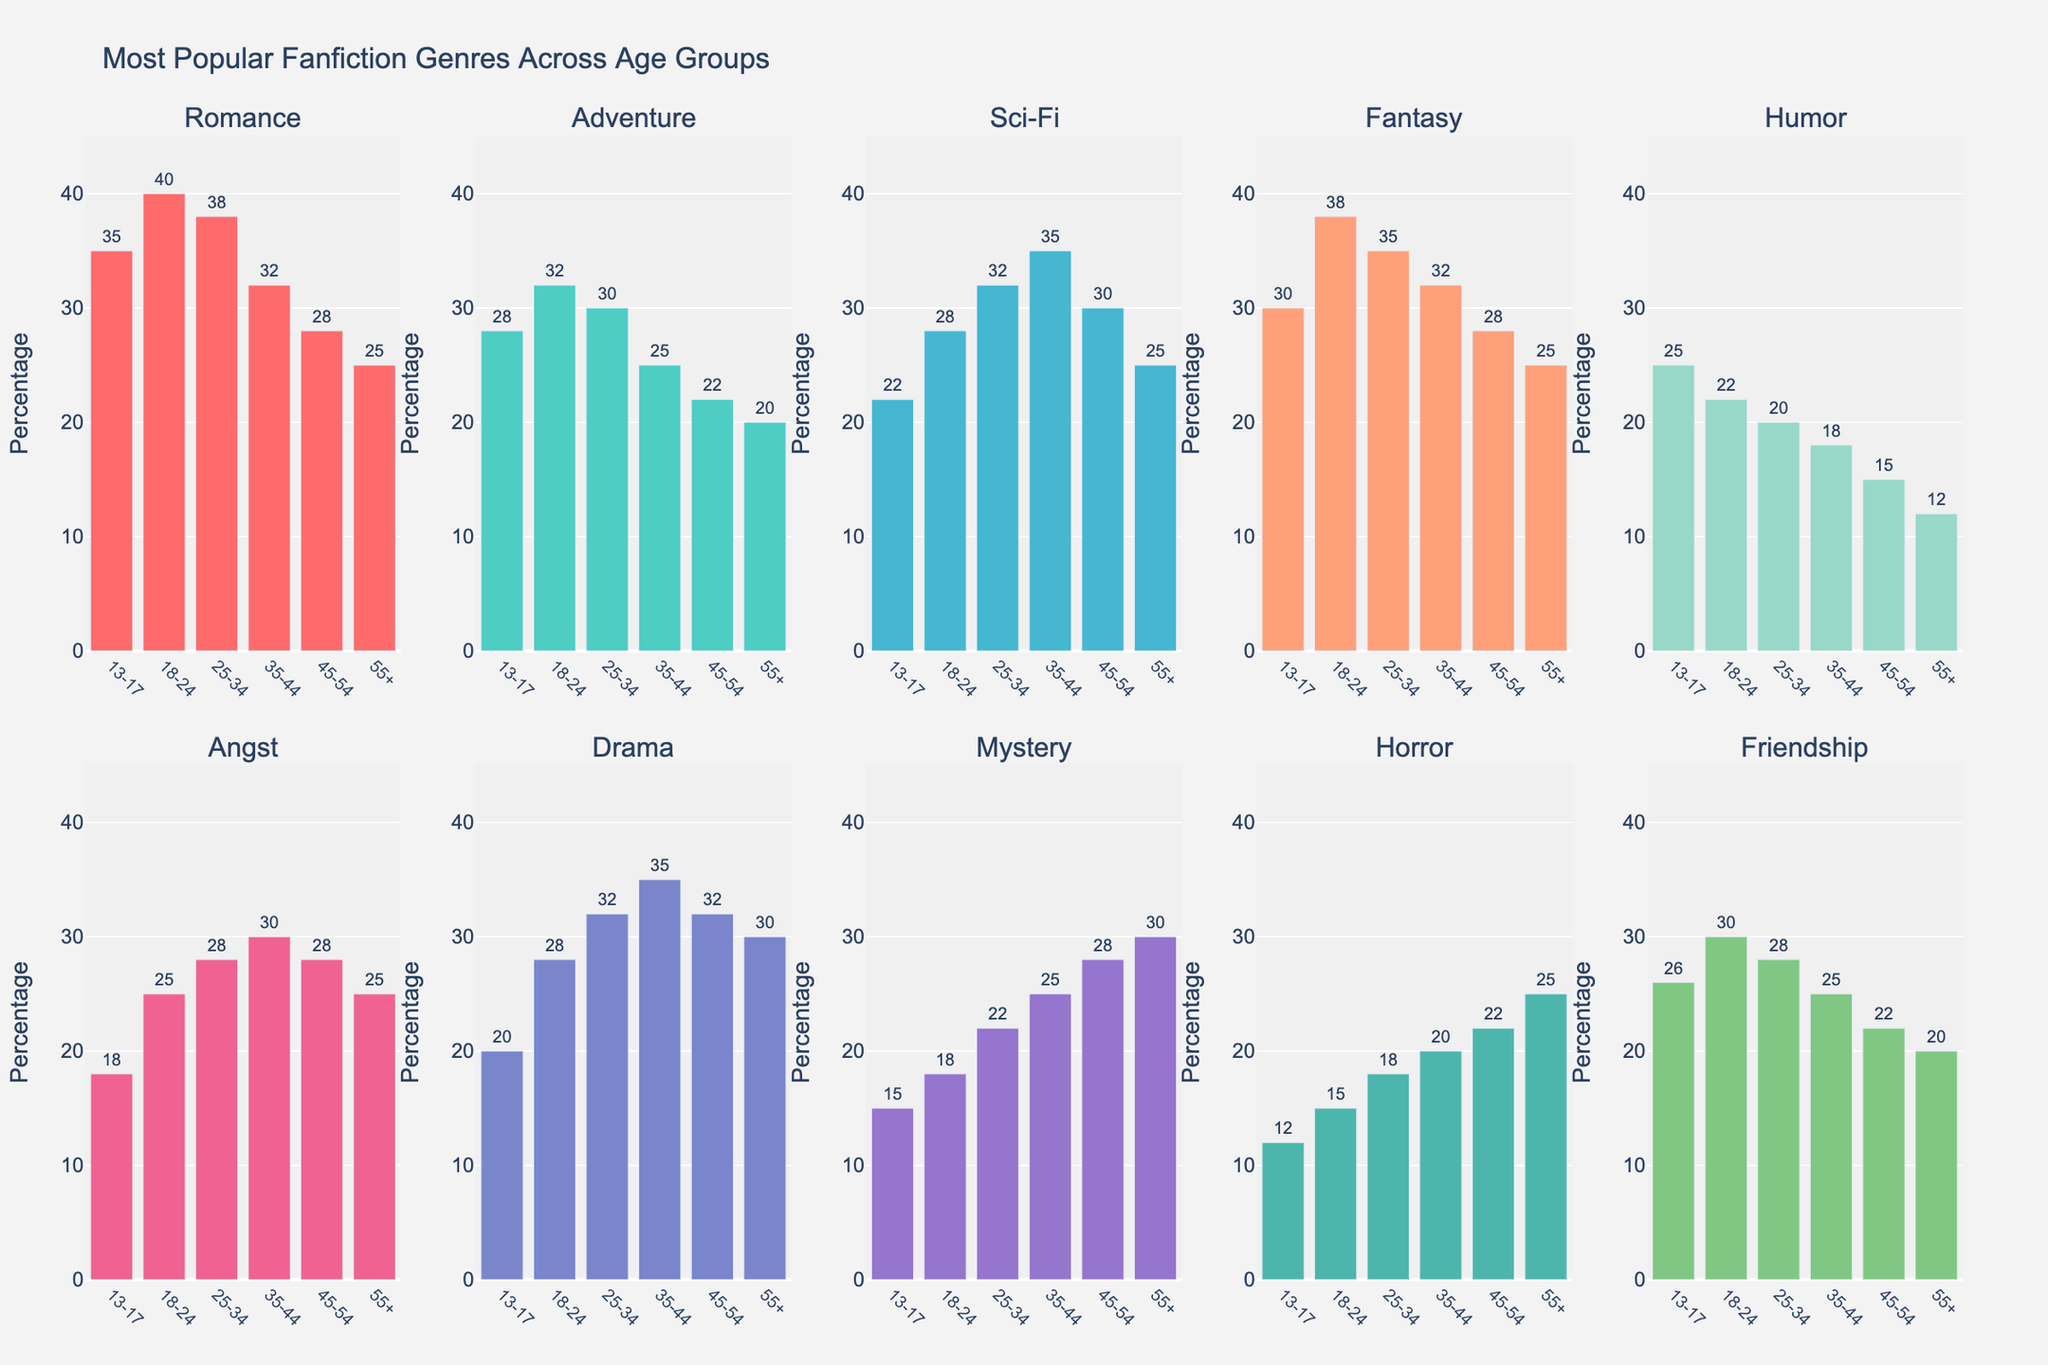What is the most popular fanfiction genre among the 13-17 age group? By observing the height of the bars for the 13-17 age group in each subplot, the Romance genre has the tallest bar at 35%.
Answer: Romance Which age group has the highest percentage of interest in Adventure fanfiction? By comparing the heights of the bars for the Adventure genre across all subplots, the 18-24 age group has the highest percentage at 32%.
Answer: 18-24 Does the Romance genre maintain the highest interest across all age groups? By examining the height of the bars for the Romance genre in each subplot, Romance is the highest for 13-17, 18-24, and 25-34 age groups. However, it is not the highest in the 35-44, 45-54, and 55+ age groups, where Drama and Mystery take precedence.
Answer: No Which genre sees a consistent decline in interest as age increases? By observing the trend in bar heights from left to right for each genre subplot, Humor shows a consistent decline as age increases from the 13-17 age group to the 55+ age group.
Answer: Humor What is the total percentage of interest in Sci-Fi and Fantasy genres among the 18-24 age group? For the 18-24 age group, Sci-Fi has 28% and Fantasy has 38%, so the total is 28 + 38 = 66%.
Answer: 66% Compare the interest in Drama and Mystery genres among the 35-44 age group. Which is more popular and by how much? In the 35-44 age group subplot, the Drama genre bar is at 35% and the Mystery genre bar is at 25%. Therefore, Drama is more popular by 35 - 25 = 10%.
Answer: Drama by 10% What is the least popular genre among the 55+ age group? By analyzing the shortest bar for the 55+ age group across all subplots, Humor has the lowest percentage at 12%.
Answer: Humor How does the interest in Horror among the 45-54 age group compare to the 13-17 age group? The bar for Horror in the 45-54 age group is at 22%, while the 13-17 age group is at 12%. Thus, Horror is more popular in the 45-54 age group by 22 - 12 = 10%.
Answer: 10% Which age group has the most equal distribution of interest across all genres? By observing the relative heights of bars within each age group subplot, the 25-34 age group shows the most equal distribution with most bars having similar heights.
Answer: 25-34 What is the average interest in Angst across all age groups? The percentages for Angst across all age groups are 18% (13-17), 25% (18-24), 28% (25-34), 30% (35-44), 28% (45-54), and 25% (55+). The average is (18 + 25 + 28 + 30 + 28 + 25) / 6 = 25.67%.
Answer: 25.67% 